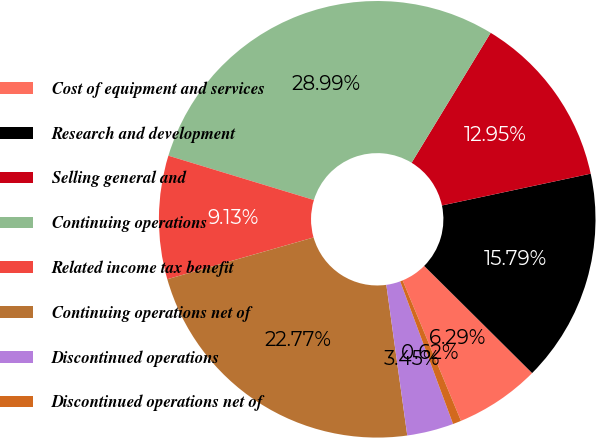Convert chart. <chart><loc_0><loc_0><loc_500><loc_500><pie_chart><fcel>Cost of equipment and services<fcel>Research and development<fcel>Selling general and<fcel>Continuing operations<fcel>Related income tax benefit<fcel>Continuing operations net of<fcel>Discontinued operations<fcel>Discontinued operations net of<nl><fcel>6.29%<fcel>15.79%<fcel>12.95%<fcel>28.99%<fcel>9.13%<fcel>22.77%<fcel>3.45%<fcel>0.62%<nl></chart> 